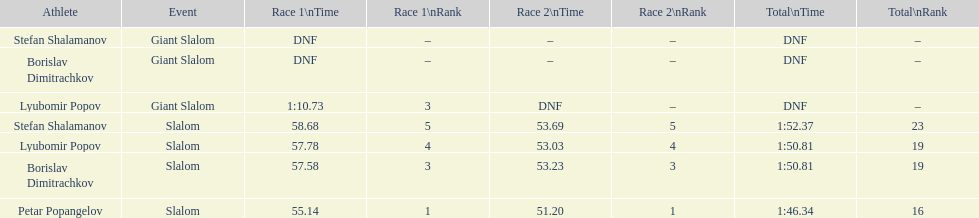Who came after borislav dimitrachkov and it's time for slalom Petar Popangelov. 